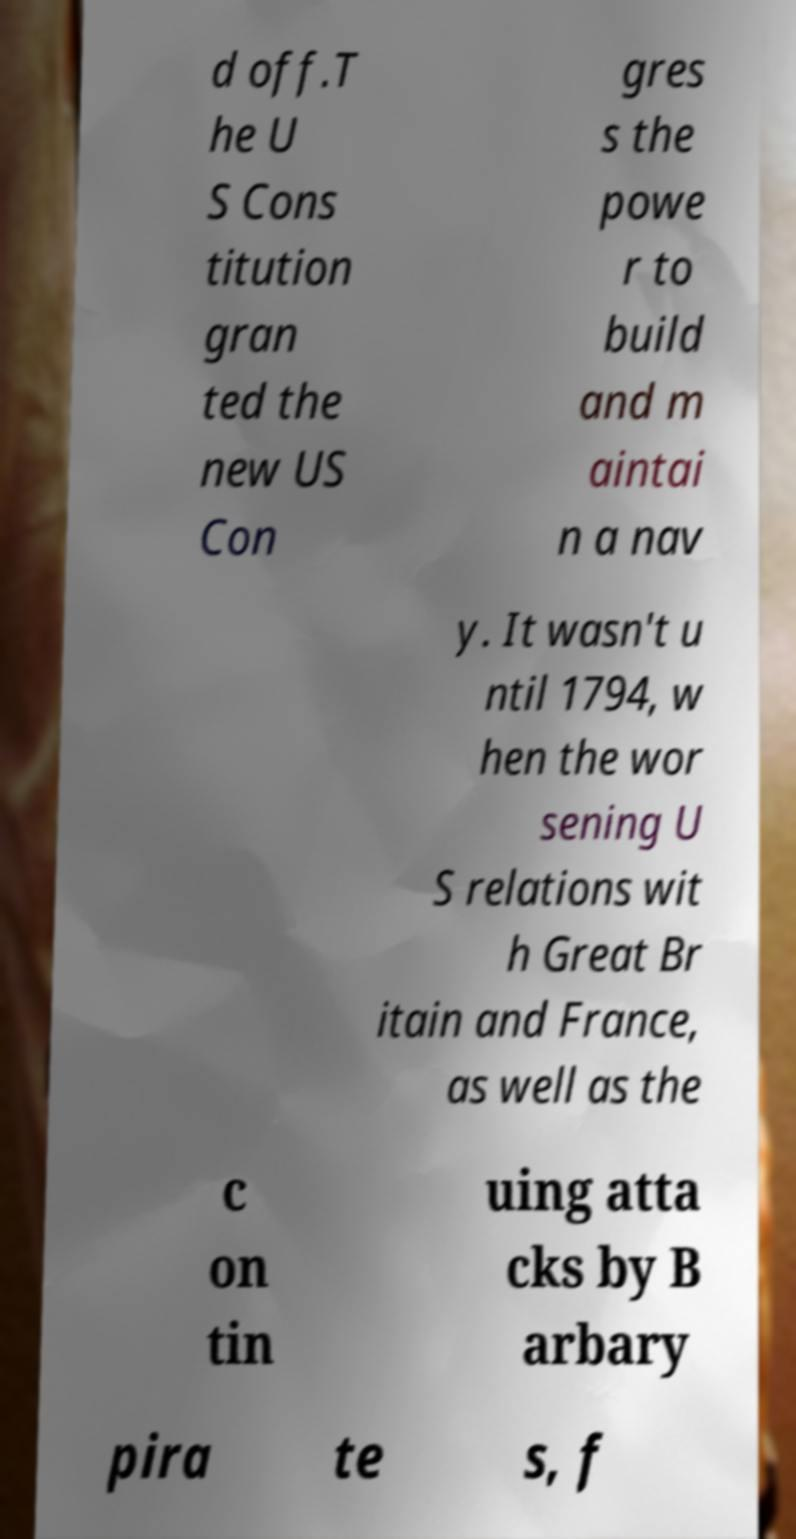Please identify and transcribe the text found in this image. d off.T he U S Cons titution gran ted the new US Con gres s the powe r to build and m aintai n a nav y. It wasn't u ntil 1794, w hen the wor sening U S relations wit h Great Br itain and France, as well as the c on tin uing atta cks by B arbary pira te s, f 